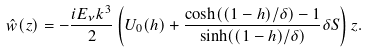Convert formula to latex. <formula><loc_0><loc_0><loc_500><loc_500>\hat { w } ( z ) = - \frac { i E _ { \nu } k ^ { 3 } } { 2 } \left ( U _ { 0 } ( h ) + \frac { \cosh ( ( 1 - h ) / \delta ) - 1 } { \sinh ( ( 1 - h ) / \delta ) } \delta S \right ) z .</formula> 